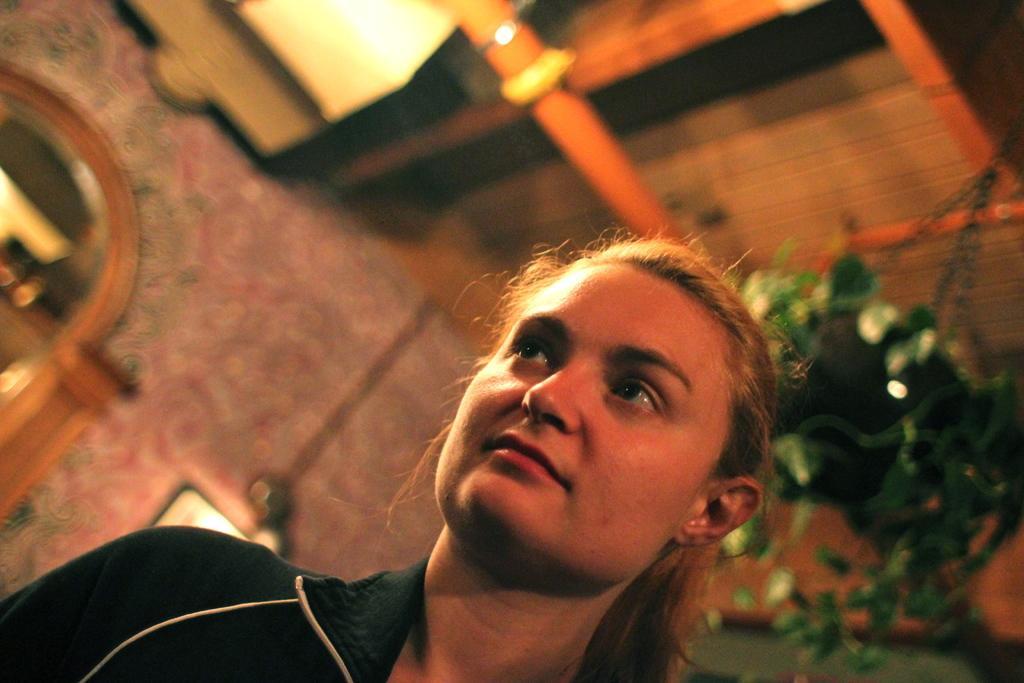Could you give a brief overview of what you see in this image? In this image, we can see a girl wearing clothes and standing. We can see a blurred background. 